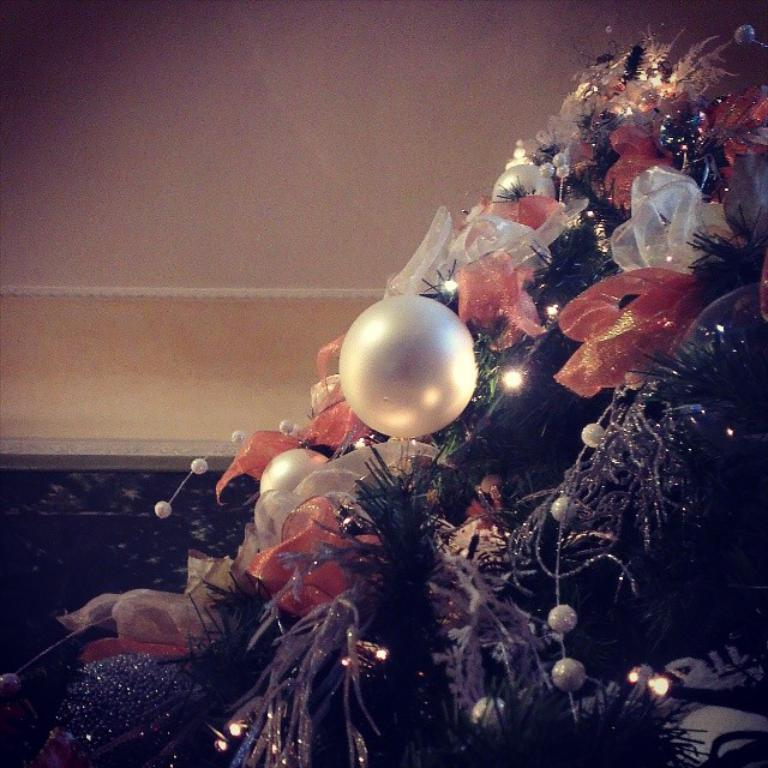What type of objects can be seen floating in the image? There are balloons in the image. What else can be seen in the image besides balloons? There are lights, ribbons, and decorative items visible in the image. What is the surface that the balloons and other objects are resting on or near? The floor is visible in the image. What can be seen in the background of the image? There is a wall in the background of the image. What type of bun is being used to hold the decorative items in the image? There is no bun present in the image; the decorative items are attached to balloons, lights, and ribbons. Can you see any mountains in the image? There are no mountains visible in the image. 